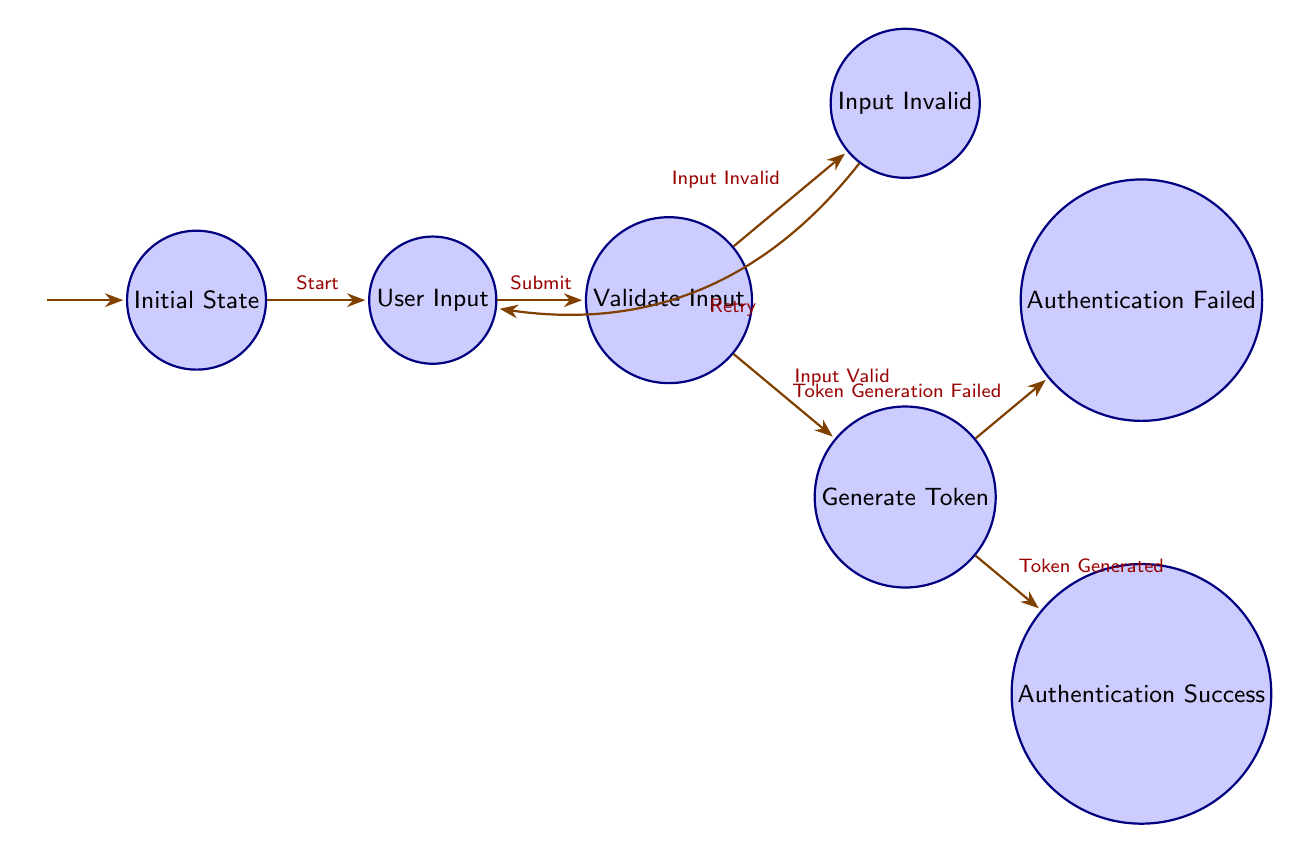What is the initial state? The initial state of the Finite State Machine is labeled "Initial State," as indicated in the diagram.
Answer: Initial State How many states are there in total? Counting all the distinct states listed in the diagram yields a total of seven states: Initial State, User Input, Validate Input, Input Invalid, Generate Token, Authentication Failed, and Authentication Success.
Answer: 7 What action leads from User Input to Validate Input? The transition from User Input to Validate Input is triggered by the action "Submit," as shown in the diagram.
Answer: Submit Which state does the diagram go to if the input is invalid? If the input is invalid, the diagram transitions to the "Input Invalid" state after the "Validate Input" state checks the input.
Answer: Input Invalid What happens after the Generate Token state if token generation is successful? If the token is successfully generated, the diagram flows into the "Authentication Success" state following the Generate Token state.
Answer: Authentication Success What action will take you back to User Input from Input Invalid? The transition that takes one back to User Input from Input Invalid is "Retry," indicating the user has the option to attempt input again.
Answer: Retry Is there a transition from Authentication Failed back to any previous state? No, the diagram does not provide a transition from the "Authentication Failed" state back to any other state; it indicates a terminal point in the process.
Answer: No Which state is directly after Validate Input if the input is valid? After a valid input is confirmed in the "Validate Input" state, the next state the process transitions to is "Generate Token."
Answer: Generate Token How many transitions are there in this diagram? By counting the arrows connecting the states, there are a total of six transitions represented in the diagram.
Answer: 6 